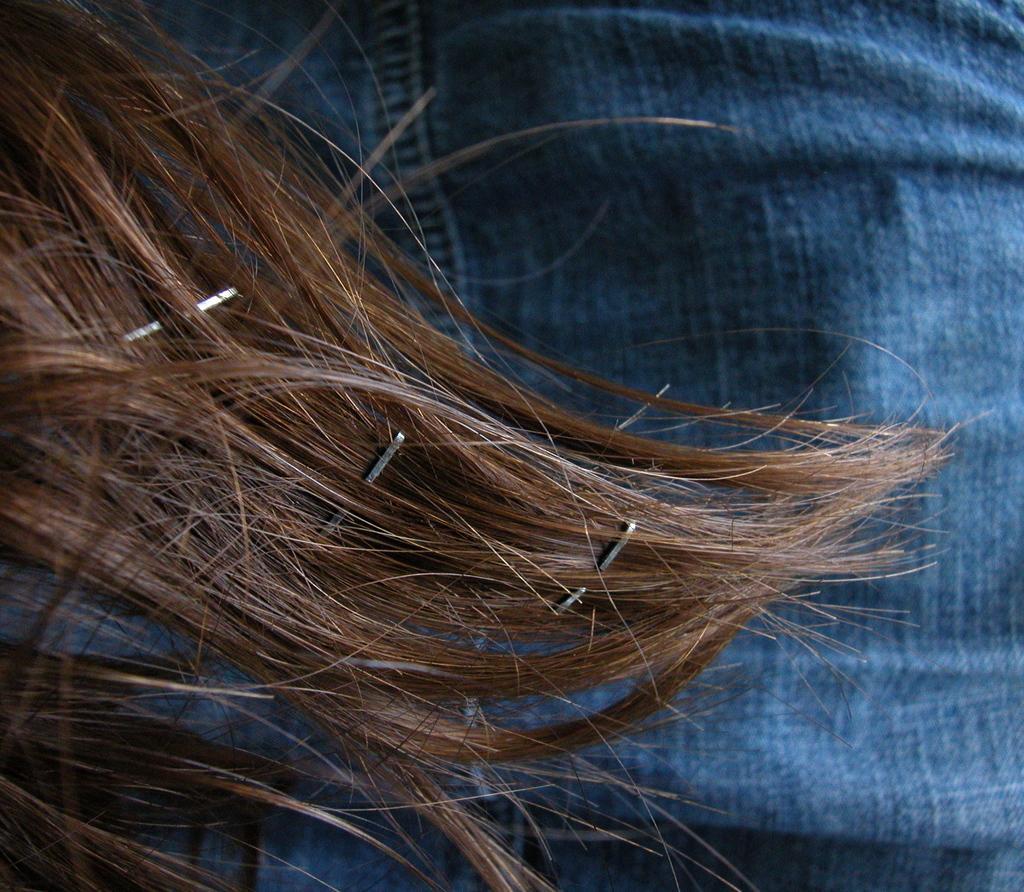Please provide a concise description of this image. There are hair in the foreground area of the image and there is a jeans in the background area. 